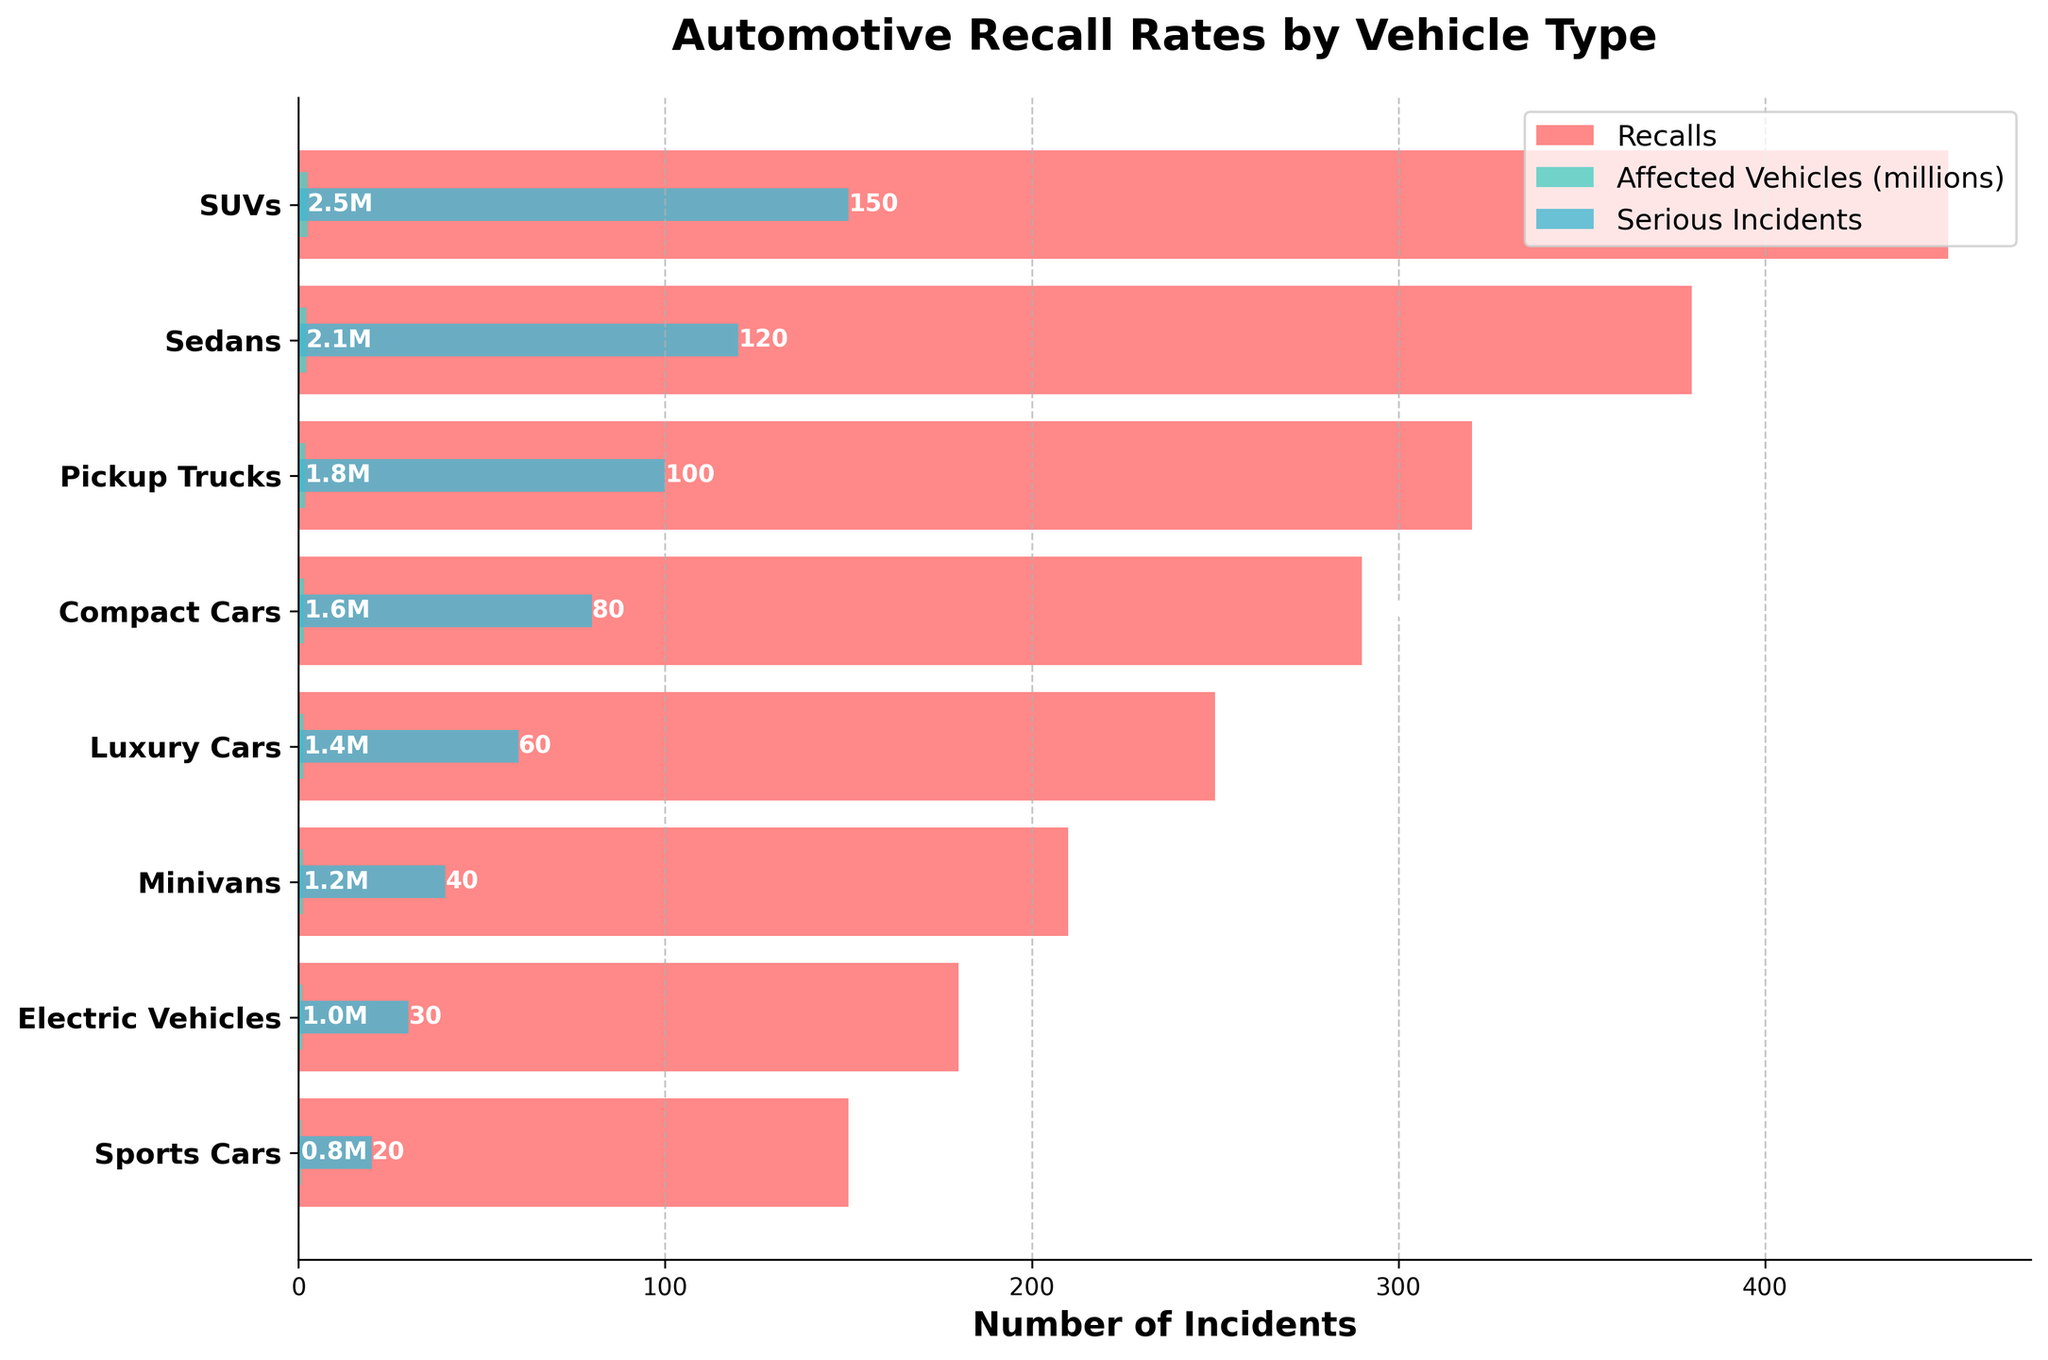What is the title of the figure? Look at the top of the figure; the title is usually prominently displayed.
Answer: Automotive Recall Rates by Vehicle Type Which vehicle type has the highest number of recalls? Identify the longest red bar (Recalls) on the left side of the funnel chart.
Answer: SUVs How many serious incidents are associated with electric vehicles? Locate the electric vehicles row and identify the length of the light blue bar (Serious Incidents).
Answer: 30 Which country has the most vehicle types listed in the top three for recalls? Examine the origins of the top three vehicle types with the longest red bars and count the occurrences.
Answer: United States What is the combined number of affected vehicles for SUVs and pickup trucks? Add the values for affected vehicles (green bars) for SUVs and pickup trucks (2.5M for SUVs + 1.8M for pickup trucks).
Answer: 4.3 million Which vehicle type has the smallest number of serious incidents? Identify the shortest light blue bar (Serious Incidents) on the right side of the funnel chart.
Answer: Sports Cars How do the affected vehicles for minivans compare to compact cars? Compare the lengths of the green bars for minivans and compact cars.
Answer: Compact cars have more affected vehicles What is the difference in the number of recalls between sedans and sports cars? Subtract the number of recalls for sports cars from the number of recalls for sedans (380 - 150).
Answer: 230 Which vehicle type has the largest ratio of serious incidents to recalls? For each vehicle type, calculate the ratio of serious incidents to recalls (e.g., SUVs: 150/450 = 0.33). Compare the ratios to find the largest.
Answer: Pickup Trucks How many total vehicle types are there in the chart? Count the unique vehicle types listed on the y-axis.
Answer: 8 